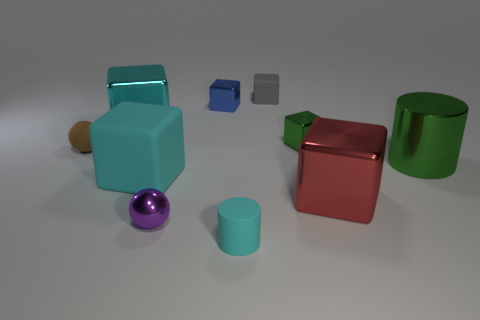How many purple metal things are left of the green object that is on the right side of the green shiny thing that is to the left of the red block?
Offer a very short reply. 1. Are there any other things that are the same color as the large metal cylinder?
Provide a short and direct response. Yes. There is a matte object that is to the right of the cyan cylinder; is it the same size as the tiny green shiny cube?
Make the answer very short. Yes. What number of blue blocks are right of the big shiny cube in front of the large cyan shiny block?
Ensure brevity in your answer.  0. There is a thing in front of the sphere that is in front of the big green shiny thing; is there a brown rubber object to the right of it?
Make the answer very short. No. What is the material of the small purple object that is the same shape as the tiny brown thing?
Offer a very short reply. Metal. Is the tiny brown thing made of the same material as the large cyan block in front of the brown sphere?
Provide a short and direct response. Yes. There is a small brown matte object that is behind the small ball in front of the red block; what shape is it?
Keep it short and to the point. Sphere. What number of large things are green metallic things or rubber spheres?
Provide a short and direct response. 1. What number of big objects are the same shape as the tiny green metal object?
Provide a short and direct response. 3. 